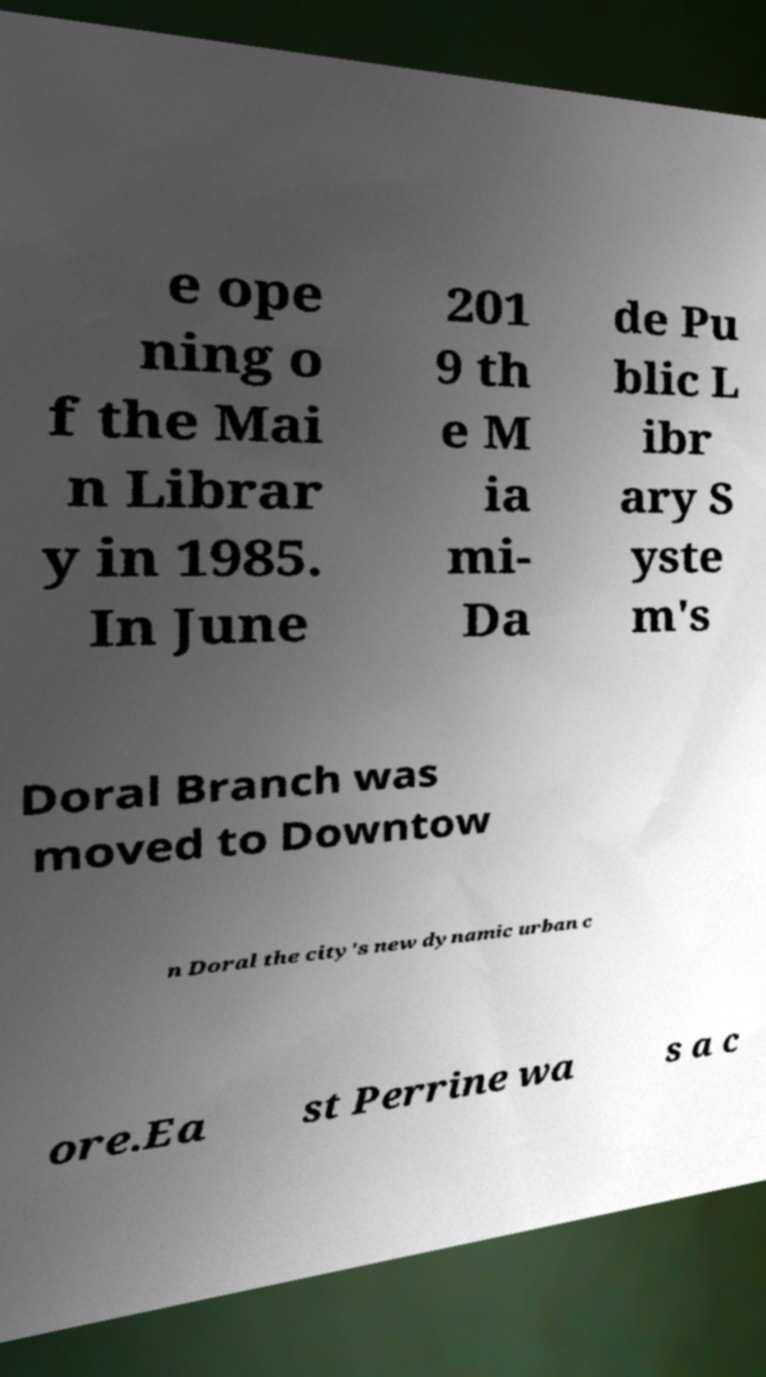Can you read and provide the text displayed in the image?This photo seems to have some interesting text. Can you extract and type it out for me? e ope ning o f the Mai n Librar y in 1985. In June 201 9 th e M ia mi- Da de Pu blic L ibr ary S yste m's Doral Branch was moved to Downtow n Doral the city's new dynamic urban c ore.Ea st Perrine wa s a c 